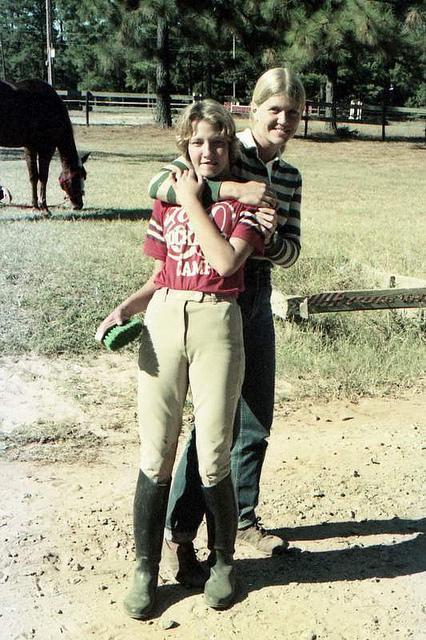How many people are there?
Give a very brief answer. 2. How many cake slices are cut and ready to eat?
Give a very brief answer. 0. 